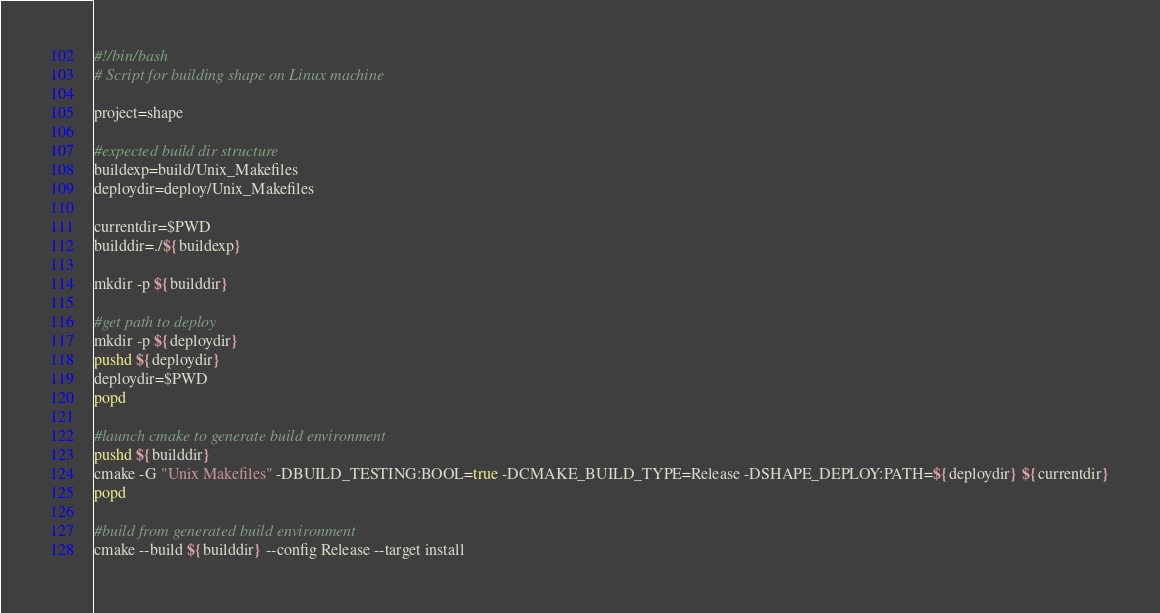<code> <loc_0><loc_0><loc_500><loc_500><_Bash_>#!/bin/bash
# Script for building shape on Linux machine

project=shape

#expected build dir structure
buildexp=build/Unix_Makefiles
deploydir=deploy/Unix_Makefiles

currentdir=$PWD
builddir=./${buildexp}

mkdir -p ${builddir}

#get path to deploy
mkdir -p ${deploydir}
pushd ${deploydir}
deploydir=$PWD
popd

#launch cmake to generate build environment
pushd ${builddir}
cmake -G "Unix Makefiles" -DBUILD_TESTING:BOOL=true -DCMAKE_BUILD_TYPE=Release -DSHAPE_DEPLOY:PATH=${deploydir} ${currentdir}
popd

#build from generated build environment
cmake --build ${builddir} --config Release --target install


</code> 